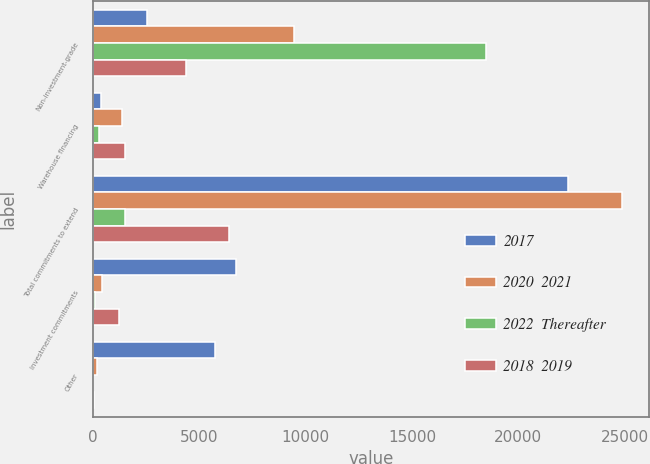Convert chart. <chart><loc_0><loc_0><loc_500><loc_500><stacked_bar_chart><ecel><fcel>Non-investment-grade<fcel>Warehouse financing<fcel>Total commitments to extend<fcel>Investment commitments<fcel>Other<nl><fcel>2017<fcel>2562<fcel>388<fcel>22358<fcel>6713<fcel>5756<nl><fcel>2020  2021<fcel>9458<fcel>1356<fcel>24905<fcel>415<fcel>200<nl><fcel>2022  Thereafter<fcel>18484<fcel>263<fcel>1507<fcel>108<fcel>15<nl><fcel>2018  2019<fcel>4374<fcel>1507<fcel>6381<fcel>1208<fcel>43<nl></chart> 